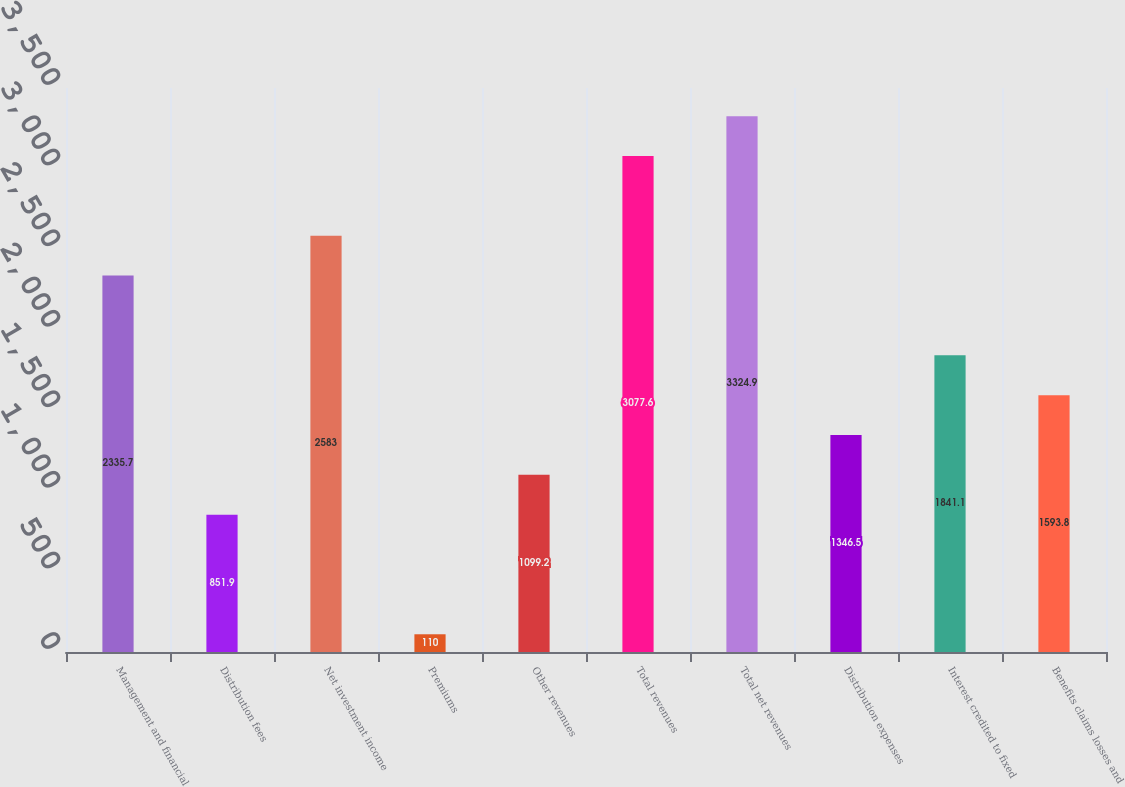Convert chart. <chart><loc_0><loc_0><loc_500><loc_500><bar_chart><fcel>Management and financial<fcel>Distribution fees<fcel>Net investment income<fcel>Premiums<fcel>Other revenues<fcel>Total revenues<fcel>Total net revenues<fcel>Distribution expenses<fcel>Interest credited to fixed<fcel>Benefits claims losses and<nl><fcel>2335.7<fcel>851.9<fcel>2583<fcel>110<fcel>1099.2<fcel>3077.6<fcel>3324.9<fcel>1346.5<fcel>1841.1<fcel>1593.8<nl></chart> 